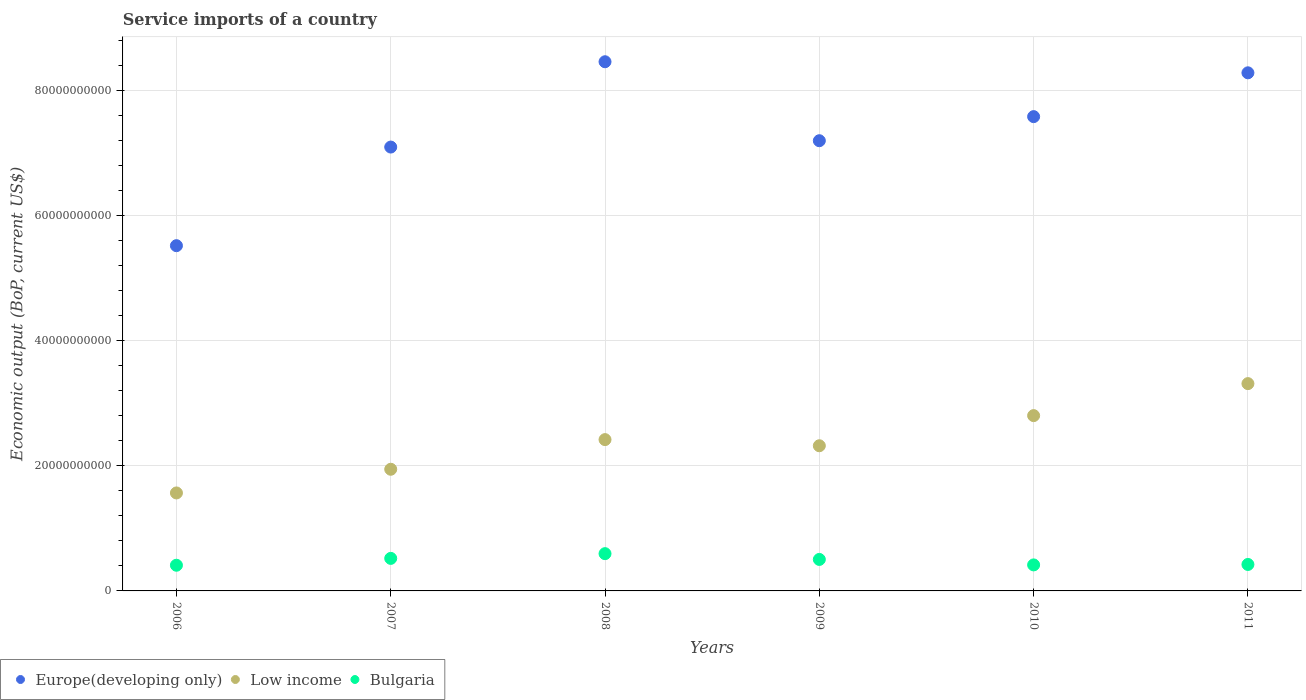How many different coloured dotlines are there?
Your answer should be compact. 3. What is the service imports in Low income in 2010?
Make the answer very short. 2.80e+1. Across all years, what is the maximum service imports in Low income?
Your answer should be very brief. 3.31e+1. Across all years, what is the minimum service imports in Low income?
Provide a short and direct response. 1.57e+1. In which year was the service imports in Low income minimum?
Offer a very short reply. 2006. What is the total service imports in Bulgaria in the graph?
Provide a short and direct response. 2.87e+1. What is the difference between the service imports in Europe(developing only) in 2006 and that in 2007?
Provide a succinct answer. -1.58e+1. What is the difference between the service imports in Low income in 2008 and the service imports in Europe(developing only) in 2007?
Provide a succinct answer. -4.68e+1. What is the average service imports in Low income per year?
Offer a terse response. 2.39e+1. In the year 2011, what is the difference between the service imports in Europe(developing only) and service imports in Low income?
Offer a very short reply. 4.97e+1. What is the ratio of the service imports in Low income in 2009 to that in 2011?
Ensure brevity in your answer.  0.7. Is the service imports in Low income in 2008 less than that in 2011?
Keep it short and to the point. Yes. Is the difference between the service imports in Europe(developing only) in 2006 and 2011 greater than the difference between the service imports in Low income in 2006 and 2011?
Ensure brevity in your answer.  No. What is the difference between the highest and the second highest service imports in Low income?
Make the answer very short. 5.12e+09. What is the difference between the highest and the lowest service imports in Low income?
Keep it short and to the point. 1.75e+1. In how many years, is the service imports in Bulgaria greater than the average service imports in Bulgaria taken over all years?
Your answer should be very brief. 3. Is it the case that in every year, the sum of the service imports in Bulgaria and service imports in Europe(developing only)  is greater than the service imports in Low income?
Your answer should be compact. Yes. Is the service imports in Bulgaria strictly greater than the service imports in Europe(developing only) over the years?
Your response must be concise. No. How many years are there in the graph?
Offer a very short reply. 6. What is the difference between two consecutive major ticks on the Y-axis?
Offer a very short reply. 2.00e+1. Are the values on the major ticks of Y-axis written in scientific E-notation?
Provide a succinct answer. No. Where does the legend appear in the graph?
Offer a terse response. Bottom left. How are the legend labels stacked?
Offer a very short reply. Horizontal. What is the title of the graph?
Keep it short and to the point. Service imports of a country. What is the label or title of the X-axis?
Your answer should be very brief. Years. What is the label or title of the Y-axis?
Make the answer very short. Economic output (BoP, current US$). What is the Economic output (BoP, current US$) of Europe(developing only) in 2006?
Provide a short and direct response. 5.52e+1. What is the Economic output (BoP, current US$) in Low income in 2006?
Offer a very short reply. 1.57e+1. What is the Economic output (BoP, current US$) in Bulgaria in 2006?
Ensure brevity in your answer.  4.11e+09. What is the Economic output (BoP, current US$) in Europe(developing only) in 2007?
Provide a short and direct response. 7.10e+1. What is the Economic output (BoP, current US$) in Low income in 2007?
Ensure brevity in your answer.  1.94e+1. What is the Economic output (BoP, current US$) of Bulgaria in 2007?
Your answer should be very brief. 5.20e+09. What is the Economic output (BoP, current US$) of Europe(developing only) in 2008?
Provide a short and direct response. 8.46e+1. What is the Economic output (BoP, current US$) of Low income in 2008?
Make the answer very short. 2.42e+1. What is the Economic output (BoP, current US$) in Bulgaria in 2008?
Your answer should be very brief. 5.96e+09. What is the Economic output (BoP, current US$) in Europe(developing only) in 2009?
Your response must be concise. 7.20e+1. What is the Economic output (BoP, current US$) of Low income in 2009?
Your response must be concise. 2.32e+1. What is the Economic output (BoP, current US$) in Bulgaria in 2009?
Your answer should be very brief. 5.03e+09. What is the Economic output (BoP, current US$) of Europe(developing only) in 2010?
Your answer should be very brief. 7.58e+1. What is the Economic output (BoP, current US$) in Low income in 2010?
Make the answer very short. 2.80e+1. What is the Economic output (BoP, current US$) of Bulgaria in 2010?
Make the answer very short. 4.16e+09. What is the Economic output (BoP, current US$) of Europe(developing only) in 2011?
Provide a short and direct response. 8.28e+1. What is the Economic output (BoP, current US$) of Low income in 2011?
Make the answer very short. 3.31e+1. What is the Economic output (BoP, current US$) of Bulgaria in 2011?
Your response must be concise. 4.23e+09. Across all years, what is the maximum Economic output (BoP, current US$) of Europe(developing only)?
Make the answer very short. 8.46e+1. Across all years, what is the maximum Economic output (BoP, current US$) in Low income?
Offer a terse response. 3.31e+1. Across all years, what is the maximum Economic output (BoP, current US$) in Bulgaria?
Your answer should be compact. 5.96e+09. Across all years, what is the minimum Economic output (BoP, current US$) of Europe(developing only)?
Your answer should be compact. 5.52e+1. Across all years, what is the minimum Economic output (BoP, current US$) in Low income?
Offer a very short reply. 1.57e+1. Across all years, what is the minimum Economic output (BoP, current US$) of Bulgaria?
Your answer should be compact. 4.11e+09. What is the total Economic output (BoP, current US$) in Europe(developing only) in the graph?
Ensure brevity in your answer.  4.41e+11. What is the total Economic output (BoP, current US$) of Low income in the graph?
Offer a terse response. 1.44e+11. What is the total Economic output (BoP, current US$) of Bulgaria in the graph?
Provide a succinct answer. 2.87e+1. What is the difference between the Economic output (BoP, current US$) of Europe(developing only) in 2006 and that in 2007?
Provide a succinct answer. -1.58e+1. What is the difference between the Economic output (BoP, current US$) of Low income in 2006 and that in 2007?
Your response must be concise. -3.79e+09. What is the difference between the Economic output (BoP, current US$) of Bulgaria in 2006 and that in 2007?
Give a very brief answer. -1.10e+09. What is the difference between the Economic output (BoP, current US$) of Europe(developing only) in 2006 and that in 2008?
Provide a short and direct response. -2.94e+1. What is the difference between the Economic output (BoP, current US$) of Low income in 2006 and that in 2008?
Give a very brief answer. -8.53e+09. What is the difference between the Economic output (BoP, current US$) of Bulgaria in 2006 and that in 2008?
Your response must be concise. -1.85e+09. What is the difference between the Economic output (BoP, current US$) in Europe(developing only) in 2006 and that in 2009?
Ensure brevity in your answer.  -1.68e+1. What is the difference between the Economic output (BoP, current US$) in Low income in 2006 and that in 2009?
Provide a succinct answer. -7.54e+09. What is the difference between the Economic output (BoP, current US$) of Bulgaria in 2006 and that in 2009?
Offer a terse response. -9.29e+08. What is the difference between the Economic output (BoP, current US$) in Europe(developing only) in 2006 and that in 2010?
Ensure brevity in your answer.  -2.06e+1. What is the difference between the Economic output (BoP, current US$) of Low income in 2006 and that in 2010?
Keep it short and to the point. -1.24e+1. What is the difference between the Economic output (BoP, current US$) of Bulgaria in 2006 and that in 2010?
Your answer should be compact. -5.36e+07. What is the difference between the Economic output (BoP, current US$) in Europe(developing only) in 2006 and that in 2011?
Give a very brief answer. -2.76e+1. What is the difference between the Economic output (BoP, current US$) in Low income in 2006 and that in 2011?
Ensure brevity in your answer.  -1.75e+1. What is the difference between the Economic output (BoP, current US$) in Bulgaria in 2006 and that in 2011?
Make the answer very short. -1.24e+08. What is the difference between the Economic output (BoP, current US$) in Europe(developing only) in 2007 and that in 2008?
Make the answer very short. -1.36e+1. What is the difference between the Economic output (BoP, current US$) of Low income in 2007 and that in 2008?
Provide a succinct answer. -4.74e+09. What is the difference between the Economic output (BoP, current US$) in Bulgaria in 2007 and that in 2008?
Keep it short and to the point. -7.55e+08. What is the difference between the Economic output (BoP, current US$) in Europe(developing only) in 2007 and that in 2009?
Offer a terse response. -1.01e+09. What is the difference between the Economic output (BoP, current US$) in Low income in 2007 and that in 2009?
Your answer should be compact. -3.76e+09. What is the difference between the Economic output (BoP, current US$) in Bulgaria in 2007 and that in 2009?
Your answer should be compact. 1.68e+08. What is the difference between the Economic output (BoP, current US$) in Europe(developing only) in 2007 and that in 2010?
Give a very brief answer. -4.86e+09. What is the difference between the Economic output (BoP, current US$) in Low income in 2007 and that in 2010?
Make the answer very short. -8.58e+09. What is the difference between the Economic output (BoP, current US$) in Bulgaria in 2007 and that in 2010?
Provide a succinct answer. 1.04e+09. What is the difference between the Economic output (BoP, current US$) in Europe(developing only) in 2007 and that in 2011?
Your response must be concise. -1.19e+1. What is the difference between the Economic output (BoP, current US$) in Low income in 2007 and that in 2011?
Your response must be concise. -1.37e+1. What is the difference between the Economic output (BoP, current US$) of Bulgaria in 2007 and that in 2011?
Your answer should be very brief. 9.72e+08. What is the difference between the Economic output (BoP, current US$) in Europe(developing only) in 2008 and that in 2009?
Give a very brief answer. 1.26e+1. What is the difference between the Economic output (BoP, current US$) in Low income in 2008 and that in 2009?
Ensure brevity in your answer.  9.83e+08. What is the difference between the Economic output (BoP, current US$) in Bulgaria in 2008 and that in 2009?
Give a very brief answer. 9.23e+08. What is the difference between the Economic output (BoP, current US$) in Europe(developing only) in 2008 and that in 2010?
Your response must be concise. 8.77e+09. What is the difference between the Economic output (BoP, current US$) of Low income in 2008 and that in 2010?
Provide a short and direct response. -3.83e+09. What is the difference between the Economic output (BoP, current US$) of Bulgaria in 2008 and that in 2010?
Give a very brief answer. 1.80e+09. What is the difference between the Economic output (BoP, current US$) in Europe(developing only) in 2008 and that in 2011?
Your answer should be compact. 1.77e+09. What is the difference between the Economic output (BoP, current US$) in Low income in 2008 and that in 2011?
Ensure brevity in your answer.  -8.95e+09. What is the difference between the Economic output (BoP, current US$) of Bulgaria in 2008 and that in 2011?
Provide a short and direct response. 1.73e+09. What is the difference between the Economic output (BoP, current US$) in Europe(developing only) in 2009 and that in 2010?
Provide a succinct answer. -3.85e+09. What is the difference between the Economic output (BoP, current US$) of Low income in 2009 and that in 2010?
Your answer should be compact. -4.82e+09. What is the difference between the Economic output (BoP, current US$) in Bulgaria in 2009 and that in 2010?
Give a very brief answer. 8.75e+08. What is the difference between the Economic output (BoP, current US$) in Europe(developing only) in 2009 and that in 2011?
Keep it short and to the point. -1.09e+1. What is the difference between the Economic output (BoP, current US$) in Low income in 2009 and that in 2011?
Provide a succinct answer. -9.93e+09. What is the difference between the Economic output (BoP, current US$) of Bulgaria in 2009 and that in 2011?
Your answer should be very brief. 8.04e+08. What is the difference between the Economic output (BoP, current US$) of Europe(developing only) in 2010 and that in 2011?
Offer a terse response. -7.00e+09. What is the difference between the Economic output (BoP, current US$) of Low income in 2010 and that in 2011?
Provide a succinct answer. -5.12e+09. What is the difference between the Economic output (BoP, current US$) of Bulgaria in 2010 and that in 2011?
Offer a terse response. -7.09e+07. What is the difference between the Economic output (BoP, current US$) of Europe(developing only) in 2006 and the Economic output (BoP, current US$) of Low income in 2007?
Provide a succinct answer. 3.57e+1. What is the difference between the Economic output (BoP, current US$) in Europe(developing only) in 2006 and the Economic output (BoP, current US$) in Bulgaria in 2007?
Offer a very short reply. 5.00e+1. What is the difference between the Economic output (BoP, current US$) in Low income in 2006 and the Economic output (BoP, current US$) in Bulgaria in 2007?
Keep it short and to the point. 1.05e+1. What is the difference between the Economic output (BoP, current US$) in Europe(developing only) in 2006 and the Economic output (BoP, current US$) in Low income in 2008?
Offer a terse response. 3.10e+1. What is the difference between the Economic output (BoP, current US$) of Europe(developing only) in 2006 and the Economic output (BoP, current US$) of Bulgaria in 2008?
Keep it short and to the point. 4.92e+1. What is the difference between the Economic output (BoP, current US$) of Low income in 2006 and the Economic output (BoP, current US$) of Bulgaria in 2008?
Your answer should be compact. 9.71e+09. What is the difference between the Economic output (BoP, current US$) in Europe(developing only) in 2006 and the Economic output (BoP, current US$) in Low income in 2009?
Your answer should be very brief. 3.20e+1. What is the difference between the Economic output (BoP, current US$) of Europe(developing only) in 2006 and the Economic output (BoP, current US$) of Bulgaria in 2009?
Give a very brief answer. 5.02e+1. What is the difference between the Economic output (BoP, current US$) of Low income in 2006 and the Economic output (BoP, current US$) of Bulgaria in 2009?
Ensure brevity in your answer.  1.06e+1. What is the difference between the Economic output (BoP, current US$) in Europe(developing only) in 2006 and the Economic output (BoP, current US$) in Low income in 2010?
Give a very brief answer. 2.72e+1. What is the difference between the Economic output (BoP, current US$) in Europe(developing only) in 2006 and the Economic output (BoP, current US$) in Bulgaria in 2010?
Make the answer very short. 5.10e+1. What is the difference between the Economic output (BoP, current US$) in Low income in 2006 and the Economic output (BoP, current US$) in Bulgaria in 2010?
Offer a very short reply. 1.15e+1. What is the difference between the Economic output (BoP, current US$) in Europe(developing only) in 2006 and the Economic output (BoP, current US$) in Low income in 2011?
Your answer should be very brief. 2.21e+1. What is the difference between the Economic output (BoP, current US$) of Europe(developing only) in 2006 and the Economic output (BoP, current US$) of Bulgaria in 2011?
Your answer should be very brief. 5.10e+1. What is the difference between the Economic output (BoP, current US$) of Low income in 2006 and the Economic output (BoP, current US$) of Bulgaria in 2011?
Provide a short and direct response. 1.14e+1. What is the difference between the Economic output (BoP, current US$) in Europe(developing only) in 2007 and the Economic output (BoP, current US$) in Low income in 2008?
Provide a short and direct response. 4.68e+1. What is the difference between the Economic output (BoP, current US$) in Europe(developing only) in 2007 and the Economic output (BoP, current US$) in Bulgaria in 2008?
Provide a succinct answer. 6.50e+1. What is the difference between the Economic output (BoP, current US$) in Low income in 2007 and the Economic output (BoP, current US$) in Bulgaria in 2008?
Give a very brief answer. 1.35e+1. What is the difference between the Economic output (BoP, current US$) in Europe(developing only) in 2007 and the Economic output (BoP, current US$) in Low income in 2009?
Your answer should be very brief. 4.78e+1. What is the difference between the Economic output (BoP, current US$) of Europe(developing only) in 2007 and the Economic output (BoP, current US$) of Bulgaria in 2009?
Make the answer very short. 6.59e+1. What is the difference between the Economic output (BoP, current US$) in Low income in 2007 and the Economic output (BoP, current US$) in Bulgaria in 2009?
Your answer should be very brief. 1.44e+1. What is the difference between the Economic output (BoP, current US$) of Europe(developing only) in 2007 and the Economic output (BoP, current US$) of Low income in 2010?
Give a very brief answer. 4.29e+1. What is the difference between the Economic output (BoP, current US$) in Europe(developing only) in 2007 and the Economic output (BoP, current US$) in Bulgaria in 2010?
Your answer should be very brief. 6.68e+1. What is the difference between the Economic output (BoP, current US$) in Low income in 2007 and the Economic output (BoP, current US$) in Bulgaria in 2010?
Make the answer very short. 1.53e+1. What is the difference between the Economic output (BoP, current US$) of Europe(developing only) in 2007 and the Economic output (BoP, current US$) of Low income in 2011?
Your answer should be compact. 3.78e+1. What is the difference between the Economic output (BoP, current US$) in Europe(developing only) in 2007 and the Economic output (BoP, current US$) in Bulgaria in 2011?
Your response must be concise. 6.67e+1. What is the difference between the Economic output (BoP, current US$) in Low income in 2007 and the Economic output (BoP, current US$) in Bulgaria in 2011?
Provide a succinct answer. 1.52e+1. What is the difference between the Economic output (BoP, current US$) in Europe(developing only) in 2008 and the Economic output (BoP, current US$) in Low income in 2009?
Make the answer very short. 6.14e+1. What is the difference between the Economic output (BoP, current US$) in Europe(developing only) in 2008 and the Economic output (BoP, current US$) in Bulgaria in 2009?
Offer a terse response. 7.96e+1. What is the difference between the Economic output (BoP, current US$) in Low income in 2008 and the Economic output (BoP, current US$) in Bulgaria in 2009?
Your answer should be very brief. 1.92e+1. What is the difference between the Economic output (BoP, current US$) of Europe(developing only) in 2008 and the Economic output (BoP, current US$) of Low income in 2010?
Offer a terse response. 5.66e+1. What is the difference between the Economic output (BoP, current US$) of Europe(developing only) in 2008 and the Economic output (BoP, current US$) of Bulgaria in 2010?
Provide a succinct answer. 8.04e+1. What is the difference between the Economic output (BoP, current US$) in Low income in 2008 and the Economic output (BoP, current US$) in Bulgaria in 2010?
Your response must be concise. 2.00e+1. What is the difference between the Economic output (BoP, current US$) of Europe(developing only) in 2008 and the Economic output (BoP, current US$) of Low income in 2011?
Offer a terse response. 5.15e+1. What is the difference between the Economic output (BoP, current US$) in Europe(developing only) in 2008 and the Economic output (BoP, current US$) in Bulgaria in 2011?
Provide a succinct answer. 8.04e+1. What is the difference between the Economic output (BoP, current US$) of Low income in 2008 and the Economic output (BoP, current US$) of Bulgaria in 2011?
Keep it short and to the point. 2.00e+1. What is the difference between the Economic output (BoP, current US$) in Europe(developing only) in 2009 and the Economic output (BoP, current US$) in Low income in 2010?
Provide a succinct answer. 4.39e+1. What is the difference between the Economic output (BoP, current US$) in Europe(developing only) in 2009 and the Economic output (BoP, current US$) in Bulgaria in 2010?
Your response must be concise. 6.78e+1. What is the difference between the Economic output (BoP, current US$) of Low income in 2009 and the Economic output (BoP, current US$) of Bulgaria in 2010?
Your answer should be very brief. 1.90e+1. What is the difference between the Economic output (BoP, current US$) in Europe(developing only) in 2009 and the Economic output (BoP, current US$) in Low income in 2011?
Give a very brief answer. 3.88e+1. What is the difference between the Economic output (BoP, current US$) of Europe(developing only) in 2009 and the Economic output (BoP, current US$) of Bulgaria in 2011?
Offer a very short reply. 6.77e+1. What is the difference between the Economic output (BoP, current US$) of Low income in 2009 and the Economic output (BoP, current US$) of Bulgaria in 2011?
Provide a short and direct response. 1.90e+1. What is the difference between the Economic output (BoP, current US$) of Europe(developing only) in 2010 and the Economic output (BoP, current US$) of Low income in 2011?
Make the answer very short. 4.27e+1. What is the difference between the Economic output (BoP, current US$) of Europe(developing only) in 2010 and the Economic output (BoP, current US$) of Bulgaria in 2011?
Give a very brief answer. 7.16e+1. What is the difference between the Economic output (BoP, current US$) in Low income in 2010 and the Economic output (BoP, current US$) in Bulgaria in 2011?
Offer a very short reply. 2.38e+1. What is the average Economic output (BoP, current US$) in Europe(developing only) per year?
Offer a terse response. 7.36e+1. What is the average Economic output (BoP, current US$) of Low income per year?
Your response must be concise. 2.39e+1. What is the average Economic output (BoP, current US$) of Bulgaria per year?
Provide a short and direct response. 4.78e+09. In the year 2006, what is the difference between the Economic output (BoP, current US$) of Europe(developing only) and Economic output (BoP, current US$) of Low income?
Your response must be concise. 3.95e+1. In the year 2006, what is the difference between the Economic output (BoP, current US$) in Europe(developing only) and Economic output (BoP, current US$) in Bulgaria?
Provide a short and direct response. 5.11e+1. In the year 2006, what is the difference between the Economic output (BoP, current US$) in Low income and Economic output (BoP, current US$) in Bulgaria?
Offer a very short reply. 1.16e+1. In the year 2007, what is the difference between the Economic output (BoP, current US$) in Europe(developing only) and Economic output (BoP, current US$) in Low income?
Offer a very short reply. 5.15e+1. In the year 2007, what is the difference between the Economic output (BoP, current US$) of Europe(developing only) and Economic output (BoP, current US$) of Bulgaria?
Give a very brief answer. 6.58e+1. In the year 2007, what is the difference between the Economic output (BoP, current US$) in Low income and Economic output (BoP, current US$) in Bulgaria?
Provide a short and direct response. 1.42e+1. In the year 2008, what is the difference between the Economic output (BoP, current US$) in Europe(developing only) and Economic output (BoP, current US$) in Low income?
Your response must be concise. 6.04e+1. In the year 2008, what is the difference between the Economic output (BoP, current US$) in Europe(developing only) and Economic output (BoP, current US$) in Bulgaria?
Your answer should be compact. 7.86e+1. In the year 2008, what is the difference between the Economic output (BoP, current US$) of Low income and Economic output (BoP, current US$) of Bulgaria?
Provide a short and direct response. 1.82e+1. In the year 2009, what is the difference between the Economic output (BoP, current US$) of Europe(developing only) and Economic output (BoP, current US$) of Low income?
Offer a terse response. 4.88e+1. In the year 2009, what is the difference between the Economic output (BoP, current US$) in Europe(developing only) and Economic output (BoP, current US$) in Bulgaria?
Provide a short and direct response. 6.69e+1. In the year 2009, what is the difference between the Economic output (BoP, current US$) in Low income and Economic output (BoP, current US$) in Bulgaria?
Offer a very short reply. 1.82e+1. In the year 2010, what is the difference between the Economic output (BoP, current US$) in Europe(developing only) and Economic output (BoP, current US$) in Low income?
Provide a short and direct response. 4.78e+1. In the year 2010, what is the difference between the Economic output (BoP, current US$) of Europe(developing only) and Economic output (BoP, current US$) of Bulgaria?
Ensure brevity in your answer.  7.17e+1. In the year 2010, what is the difference between the Economic output (BoP, current US$) in Low income and Economic output (BoP, current US$) in Bulgaria?
Your response must be concise. 2.39e+1. In the year 2011, what is the difference between the Economic output (BoP, current US$) in Europe(developing only) and Economic output (BoP, current US$) in Low income?
Provide a succinct answer. 4.97e+1. In the year 2011, what is the difference between the Economic output (BoP, current US$) in Europe(developing only) and Economic output (BoP, current US$) in Bulgaria?
Provide a short and direct response. 7.86e+1. In the year 2011, what is the difference between the Economic output (BoP, current US$) in Low income and Economic output (BoP, current US$) in Bulgaria?
Your answer should be very brief. 2.89e+1. What is the ratio of the Economic output (BoP, current US$) of Low income in 2006 to that in 2007?
Make the answer very short. 0.81. What is the ratio of the Economic output (BoP, current US$) in Bulgaria in 2006 to that in 2007?
Make the answer very short. 0.79. What is the ratio of the Economic output (BoP, current US$) in Europe(developing only) in 2006 to that in 2008?
Provide a succinct answer. 0.65. What is the ratio of the Economic output (BoP, current US$) of Low income in 2006 to that in 2008?
Provide a short and direct response. 0.65. What is the ratio of the Economic output (BoP, current US$) in Bulgaria in 2006 to that in 2008?
Provide a succinct answer. 0.69. What is the ratio of the Economic output (BoP, current US$) of Europe(developing only) in 2006 to that in 2009?
Give a very brief answer. 0.77. What is the ratio of the Economic output (BoP, current US$) in Low income in 2006 to that in 2009?
Provide a succinct answer. 0.68. What is the ratio of the Economic output (BoP, current US$) in Bulgaria in 2006 to that in 2009?
Your answer should be very brief. 0.82. What is the ratio of the Economic output (BoP, current US$) of Europe(developing only) in 2006 to that in 2010?
Give a very brief answer. 0.73. What is the ratio of the Economic output (BoP, current US$) of Low income in 2006 to that in 2010?
Your answer should be very brief. 0.56. What is the ratio of the Economic output (BoP, current US$) of Bulgaria in 2006 to that in 2010?
Give a very brief answer. 0.99. What is the ratio of the Economic output (BoP, current US$) of Europe(developing only) in 2006 to that in 2011?
Provide a succinct answer. 0.67. What is the ratio of the Economic output (BoP, current US$) in Low income in 2006 to that in 2011?
Offer a very short reply. 0.47. What is the ratio of the Economic output (BoP, current US$) of Bulgaria in 2006 to that in 2011?
Your answer should be very brief. 0.97. What is the ratio of the Economic output (BoP, current US$) in Europe(developing only) in 2007 to that in 2008?
Give a very brief answer. 0.84. What is the ratio of the Economic output (BoP, current US$) of Low income in 2007 to that in 2008?
Ensure brevity in your answer.  0.8. What is the ratio of the Economic output (BoP, current US$) in Bulgaria in 2007 to that in 2008?
Make the answer very short. 0.87. What is the ratio of the Economic output (BoP, current US$) in Europe(developing only) in 2007 to that in 2009?
Your response must be concise. 0.99. What is the ratio of the Economic output (BoP, current US$) of Low income in 2007 to that in 2009?
Ensure brevity in your answer.  0.84. What is the ratio of the Economic output (BoP, current US$) of Europe(developing only) in 2007 to that in 2010?
Keep it short and to the point. 0.94. What is the ratio of the Economic output (BoP, current US$) in Low income in 2007 to that in 2010?
Provide a short and direct response. 0.69. What is the ratio of the Economic output (BoP, current US$) in Bulgaria in 2007 to that in 2010?
Provide a short and direct response. 1.25. What is the ratio of the Economic output (BoP, current US$) in Europe(developing only) in 2007 to that in 2011?
Give a very brief answer. 0.86. What is the ratio of the Economic output (BoP, current US$) in Low income in 2007 to that in 2011?
Provide a short and direct response. 0.59. What is the ratio of the Economic output (BoP, current US$) of Bulgaria in 2007 to that in 2011?
Provide a succinct answer. 1.23. What is the ratio of the Economic output (BoP, current US$) in Europe(developing only) in 2008 to that in 2009?
Offer a very short reply. 1.18. What is the ratio of the Economic output (BoP, current US$) in Low income in 2008 to that in 2009?
Your response must be concise. 1.04. What is the ratio of the Economic output (BoP, current US$) in Bulgaria in 2008 to that in 2009?
Offer a very short reply. 1.18. What is the ratio of the Economic output (BoP, current US$) in Europe(developing only) in 2008 to that in 2010?
Provide a succinct answer. 1.12. What is the ratio of the Economic output (BoP, current US$) in Low income in 2008 to that in 2010?
Offer a terse response. 0.86. What is the ratio of the Economic output (BoP, current US$) of Bulgaria in 2008 to that in 2010?
Your response must be concise. 1.43. What is the ratio of the Economic output (BoP, current US$) of Europe(developing only) in 2008 to that in 2011?
Give a very brief answer. 1.02. What is the ratio of the Economic output (BoP, current US$) in Low income in 2008 to that in 2011?
Make the answer very short. 0.73. What is the ratio of the Economic output (BoP, current US$) in Bulgaria in 2008 to that in 2011?
Offer a very short reply. 1.41. What is the ratio of the Economic output (BoP, current US$) of Europe(developing only) in 2009 to that in 2010?
Your response must be concise. 0.95. What is the ratio of the Economic output (BoP, current US$) in Low income in 2009 to that in 2010?
Your response must be concise. 0.83. What is the ratio of the Economic output (BoP, current US$) of Bulgaria in 2009 to that in 2010?
Keep it short and to the point. 1.21. What is the ratio of the Economic output (BoP, current US$) in Europe(developing only) in 2009 to that in 2011?
Your answer should be compact. 0.87. What is the ratio of the Economic output (BoP, current US$) of Low income in 2009 to that in 2011?
Offer a very short reply. 0.7. What is the ratio of the Economic output (BoP, current US$) of Bulgaria in 2009 to that in 2011?
Make the answer very short. 1.19. What is the ratio of the Economic output (BoP, current US$) of Europe(developing only) in 2010 to that in 2011?
Keep it short and to the point. 0.92. What is the ratio of the Economic output (BoP, current US$) in Low income in 2010 to that in 2011?
Offer a terse response. 0.85. What is the ratio of the Economic output (BoP, current US$) of Bulgaria in 2010 to that in 2011?
Offer a very short reply. 0.98. What is the difference between the highest and the second highest Economic output (BoP, current US$) of Europe(developing only)?
Make the answer very short. 1.77e+09. What is the difference between the highest and the second highest Economic output (BoP, current US$) in Low income?
Provide a succinct answer. 5.12e+09. What is the difference between the highest and the second highest Economic output (BoP, current US$) of Bulgaria?
Give a very brief answer. 7.55e+08. What is the difference between the highest and the lowest Economic output (BoP, current US$) of Europe(developing only)?
Your answer should be compact. 2.94e+1. What is the difference between the highest and the lowest Economic output (BoP, current US$) of Low income?
Your answer should be very brief. 1.75e+1. What is the difference between the highest and the lowest Economic output (BoP, current US$) of Bulgaria?
Provide a succinct answer. 1.85e+09. 